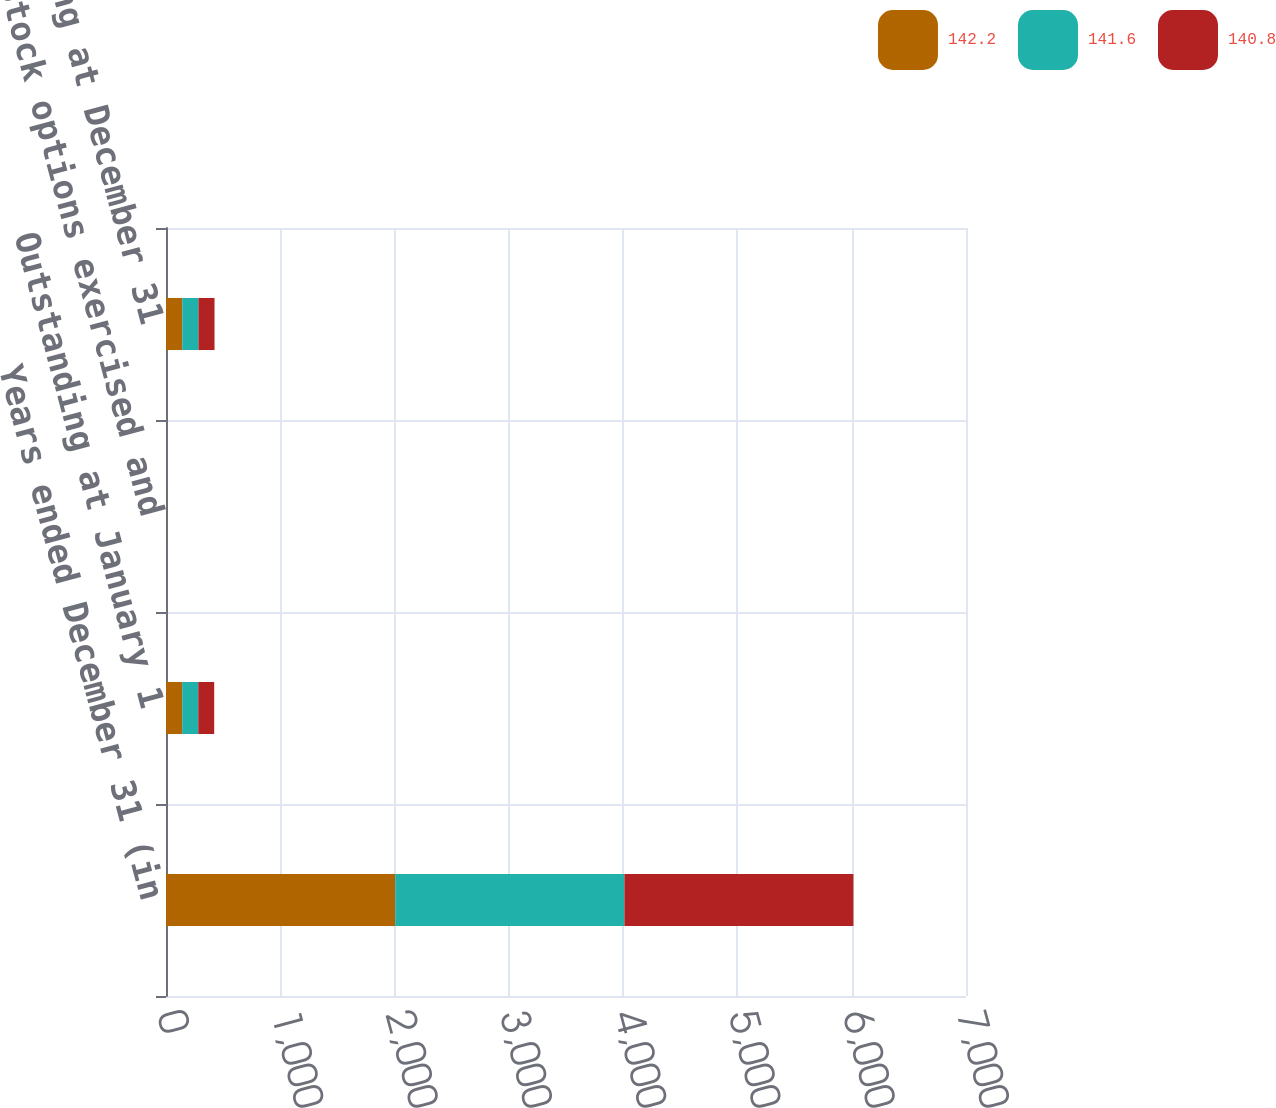Convert chart. <chart><loc_0><loc_0><loc_500><loc_500><stacked_bar_chart><ecel><fcel>Years ended December 31 (in<fcel>Outstanding at January 1<fcel>Stock options exercised and<fcel>Outstanding at December 31<nl><fcel>142.2<fcel>2006<fcel>141.6<fcel>0.6<fcel>142.2<nl><fcel>141.6<fcel>2005<fcel>140.8<fcel>0.8<fcel>141.6<nl><fcel>140.8<fcel>2004<fcel>139.5<fcel>1.3<fcel>140.8<nl></chart> 